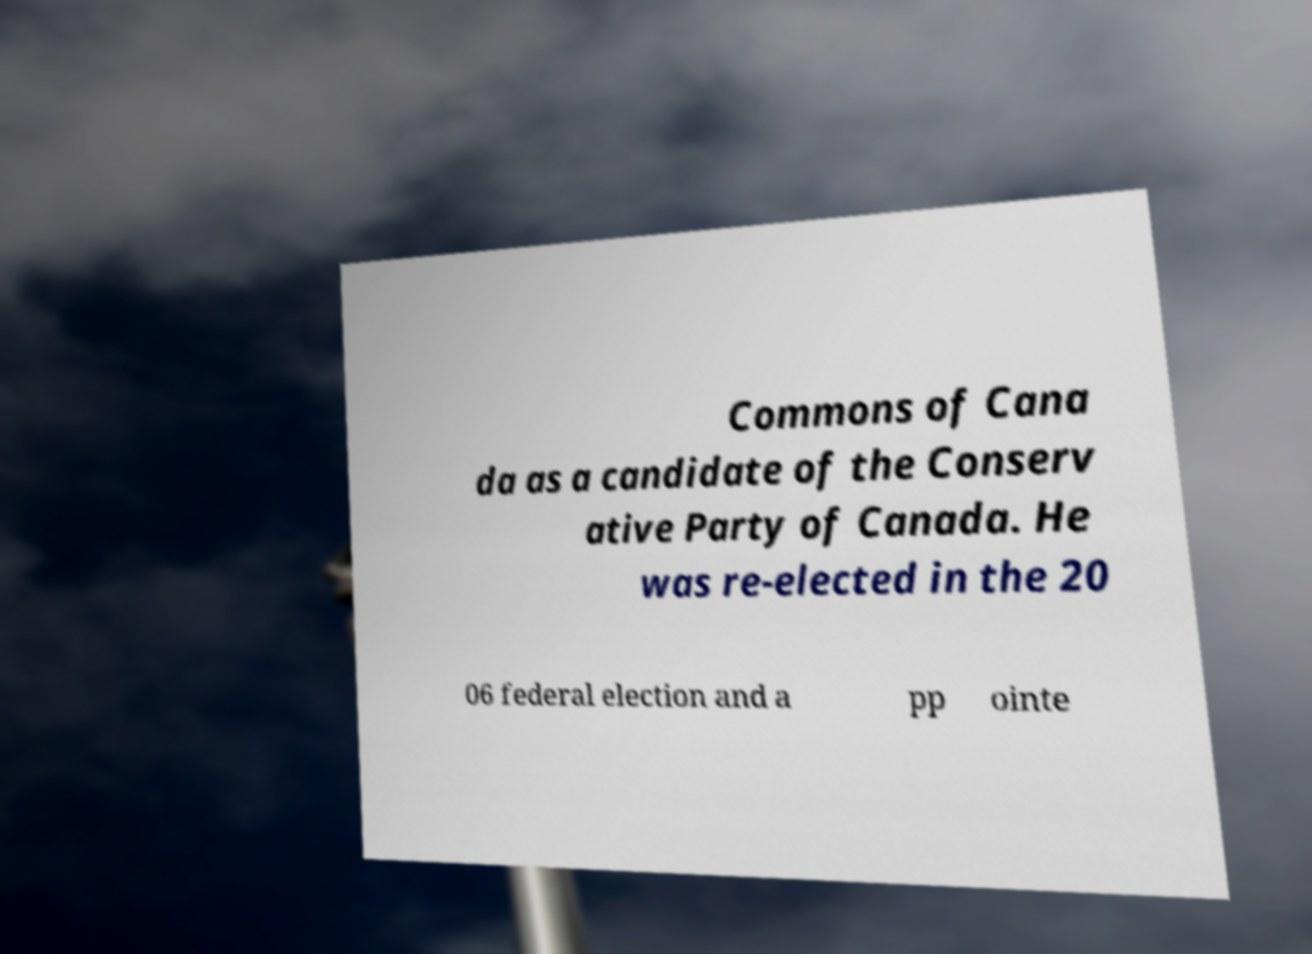There's text embedded in this image that I need extracted. Can you transcribe it verbatim? Commons of Cana da as a candidate of the Conserv ative Party of Canada. He was re-elected in the 20 06 federal election and a pp ointe 